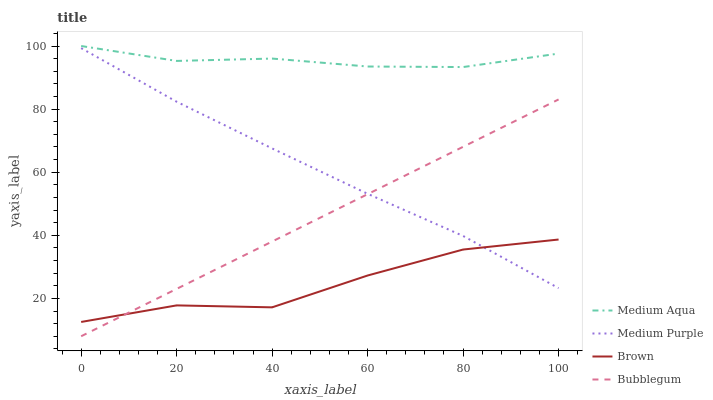Does Brown have the minimum area under the curve?
Answer yes or no. Yes. Does Medium Aqua have the maximum area under the curve?
Answer yes or no. Yes. Does Medium Aqua have the minimum area under the curve?
Answer yes or no. No. Does Brown have the maximum area under the curve?
Answer yes or no. No. Is Bubblegum the smoothest?
Answer yes or no. Yes. Is Brown the roughest?
Answer yes or no. Yes. Is Medium Aqua the smoothest?
Answer yes or no. No. Is Medium Aqua the roughest?
Answer yes or no. No. Does Bubblegum have the lowest value?
Answer yes or no. Yes. Does Brown have the lowest value?
Answer yes or no. No. Does Medium Aqua have the highest value?
Answer yes or no. Yes. Does Brown have the highest value?
Answer yes or no. No. Is Bubblegum less than Medium Aqua?
Answer yes or no. Yes. Is Medium Aqua greater than Brown?
Answer yes or no. Yes. Does Medium Purple intersect Bubblegum?
Answer yes or no. Yes. Is Medium Purple less than Bubblegum?
Answer yes or no. No. Is Medium Purple greater than Bubblegum?
Answer yes or no. No. Does Bubblegum intersect Medium Aqua?
Answer yes or no. No. 